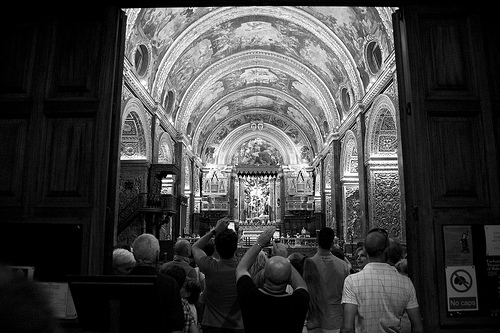Which place is it? The image depicts the interior of an ornately decorated church, characterized by elaborate arches, detailed artwork on the ceiling, and a prominent altar at the far end. 